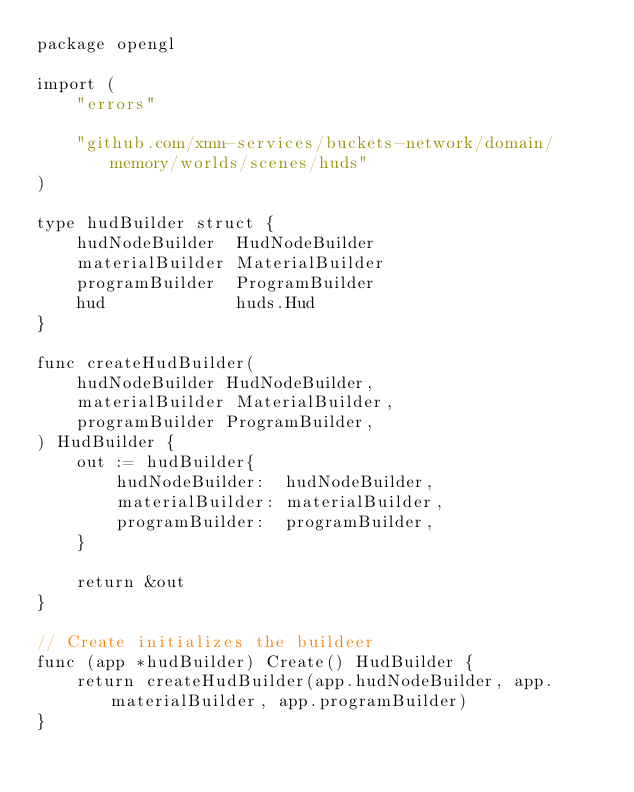<code> <loc_0><loc_0><loc_500><loc_500><_Go_>package opengl

import (
	"errors"

	"github.com/xmn-services/buckets-network/domain/memory/worlds/scenes/huds"
)

type hudBuilder struct {
	hudNodeBuilder  HudNodeBuilder
	materialBuilder MaterialBuilder
	programBuilder  ProgramBuilder
	hud             huds.Hud
}

func createHudBuilder(
	hudNodeBuilder HudNodeBuilder,
	materialBuilder MaterialBuilder,
	programBuilder ProgramBuilder,
) HudBuilder {
	out := hudBuilder{
		hudNodeBuilder:  hudNodeBuilder,
		materialBuilder: materialBuilder,
		programBuilder:  programBuilder,
	}

	return &out
}

// Create initializes the buildeer
func (app *hudBuilder) Create() HudBuilder {
	return createHudBuilder(app.hudNodeBuilder, app.materialBuilder, app.programBuilder)
}
</code> 